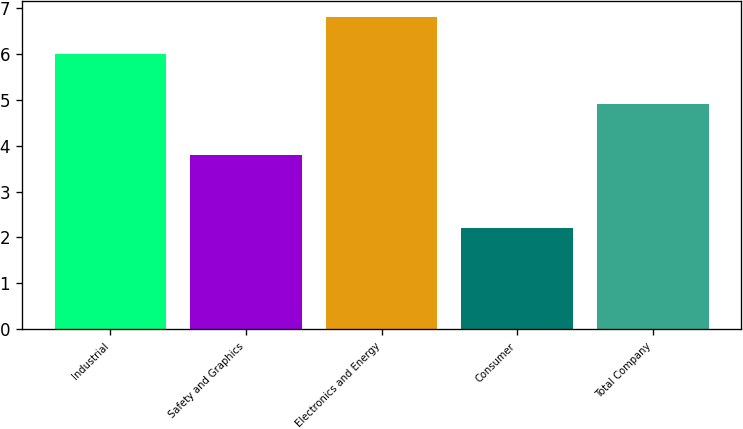<chart> <loc_0><loc_0><loc_500><loc_500><bar_chart><fcel>Industrial<fcel>Safety and Graphics<fcel>Electronics and Energy<fcel>Consumer<fcel>Total Company<nl><fcel>6<fcel>3.8<fcel>6.8<fcel>2.2<fcel>4.9<nl></chart> 